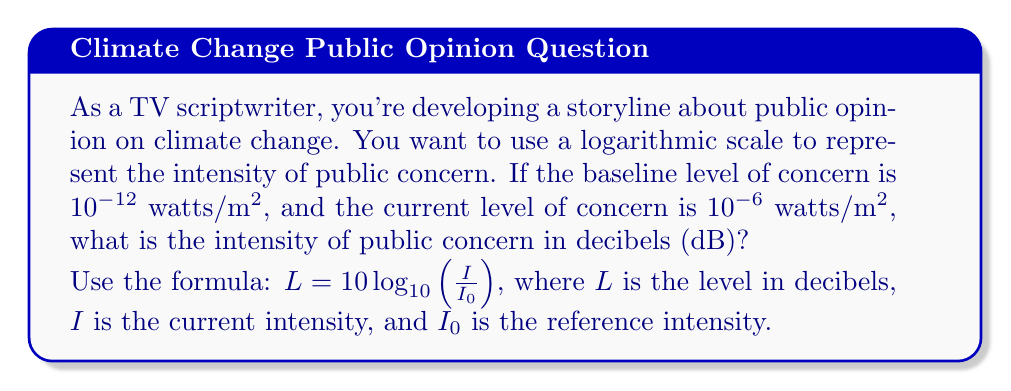Can you answer this question? Let's approach this step-by-step:

1) We're given:
   $I_0 = 10^{-12}$ watts/m^2 (baseline level)
   $I = 10^{-6}$ watts/m^2 (current level)

2) We need to use the formula: $L = 10 \log_{10}(\frac{I}{I_0})$

3) Let's substitute our values:
   $L = 10 \log_{10}(\frac{10^{-6}}{10^{-12}})$

4) Simplify inside the parentheses:
   $L = 10 \log_{10}(10^{-6+12}) = 10 \log_{10}(10^6)$

5) Apply the logarithm rule $\log_a(a^n) = n$:
   $L = 10 \cdot 6 = 60$

Therefore, the intensity of public concern is 60 dB.

This logarithmic scale allows for a more manageable representation of the large range of intensities in public opinion, similar to how sound intensity is measured.
Answer: 60 dB 